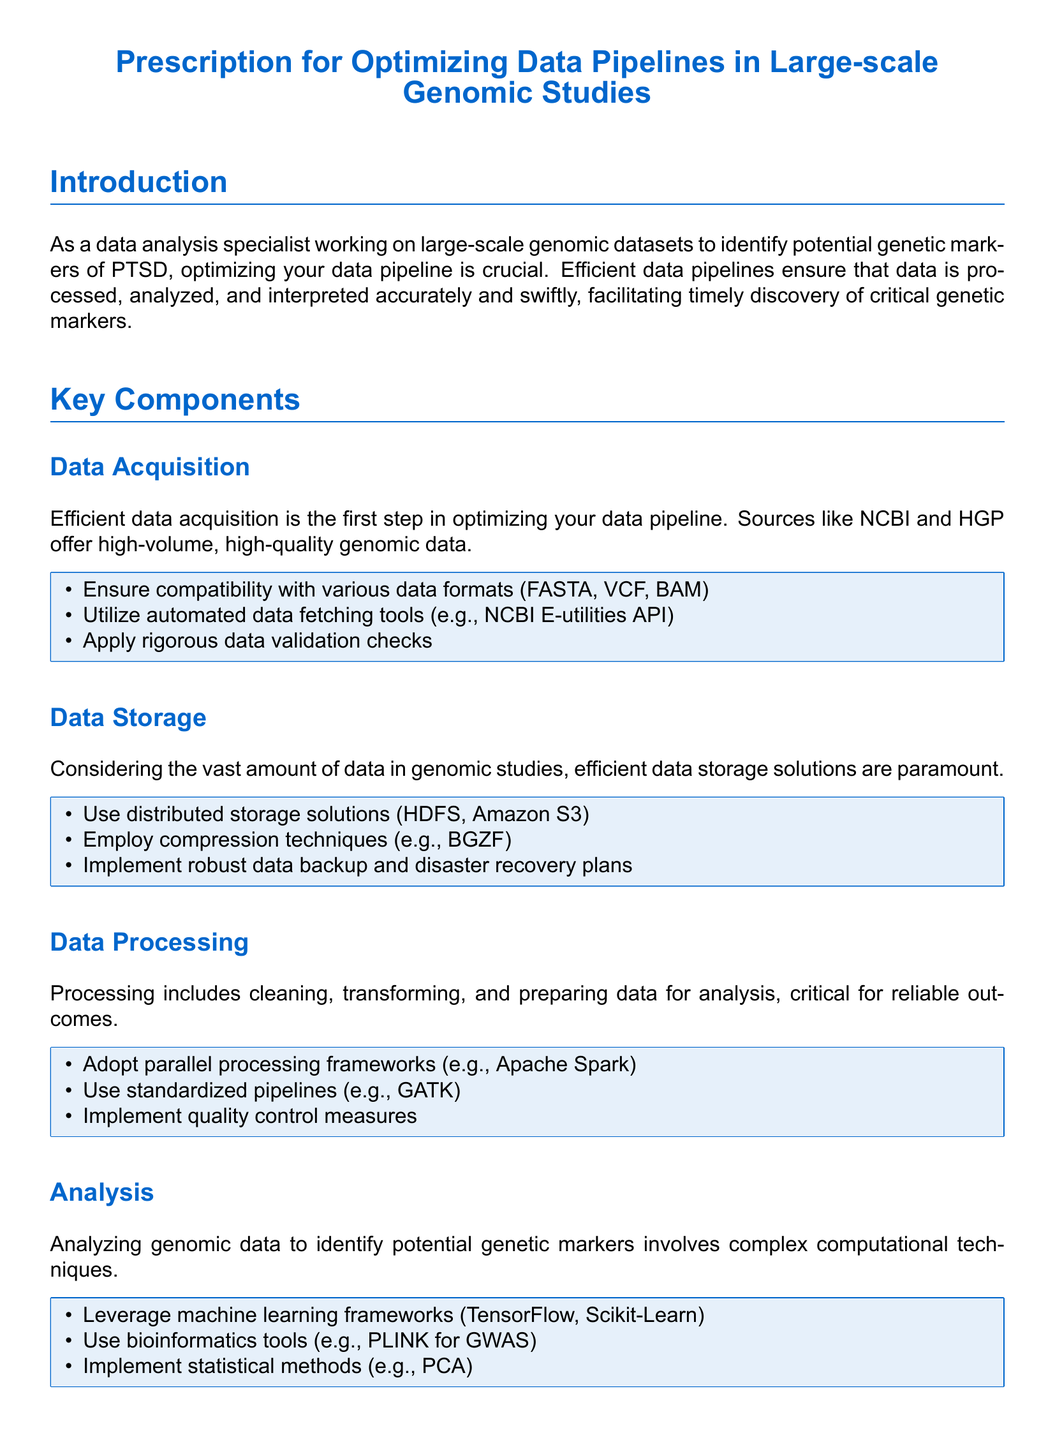What is the title of the document? The title of the document, as stated clearly at the top, is "Prescription for Optimizing Data Pipelines in Large-scale Genomic Studies."
Answer: Prescription for Optimizing Data Pipelines in Large-scale Genomic Studies How many key components are listed in the document? The document outlines six key components essential for optimizing data pipelines in genomic studies.
Answer: Six What is the first step mentioned in optimizing a data pipeline? The first step in optimizing a data pipeline according to the document is "Data Acquisition."
Answer: Data Acquisition Which automated tool is suggested for data fetching? The document recommends utilizing the "NCBI E-utilities API" for automated data fetching.
Answer: NCBI E-utilities API What technology should be adopted for data processing? The document advises adopting "parallel processing frameworks" as a technology for data processing.
Answer: Parallel processing frameworks Which cloud-based solution is mentioned for scalability? "AWS Genomics" is identified in the document as a cloud-based solution for scalability in data pipelines.
Answer: AWS Genomics What type of visualization tool is suggested? The document suggests using "Circos" for interactive data visualization.
Answer: Circos Which bioinformatics tool is mentioned for GWAS? According to the document, "PLINK" is the bioinformatics tool mentioned for conducting genome-wide association studies (GWAS).
Answer: PLINK What is emphasized for ensuring the quality of genomic data? The document emphasizes implementing "quality control measures" to ensure the quality of genomic data.
Answer: Quality control measures 